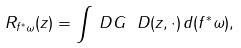Convert formula to latex. <formula><loc_0><loc_0><loc_500><loc_500>R _ { f ^ { * } \omega } ( z ) = \int _ { \ } D G _ { \ } D ( z , \cdot ) \, d ( f ^ { * } \omega ) ,</formula> 